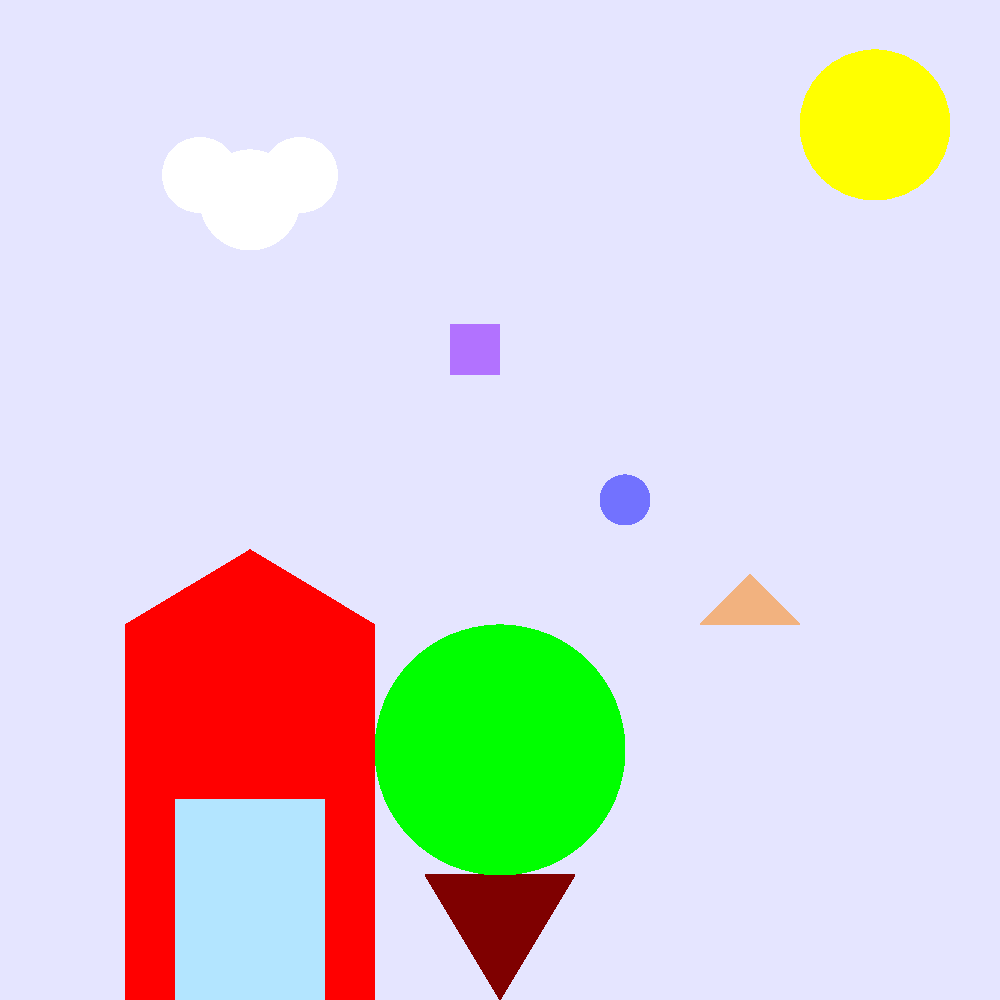In this colorful cartoon scene, how many different geometric shapes can you identify that are partially hidden or blended into the background? (Hint: Look closely at the sky, grass, and around the house) Let's examine the scene carefully to identify the hidden shapes:

1. In the sky area, slightly to the right of the cloud, there's a faint blue circle.

2. In the grass area, towards the right side of the image, there's a semi-transparent orange triangle.

3. In the middle of the image, between the house and the tree, there's a small purple square.

These shapes are intentionally made semi-transparent to blend with the background, making them challenging to spot at first glance. This type of visual puzzle encourages children to look closely and pay attention to details, enhancing their observational skills and shape recognition abilities.

The three hidden shapes (circle, triangle, and square) are distinct from the more obvious elements of the scene like the sun (circle), tree (circle and triangle), and house (rectangle and triangle), which are not considered in the count as they are not hidden or blended into the background.
Answer: 3 